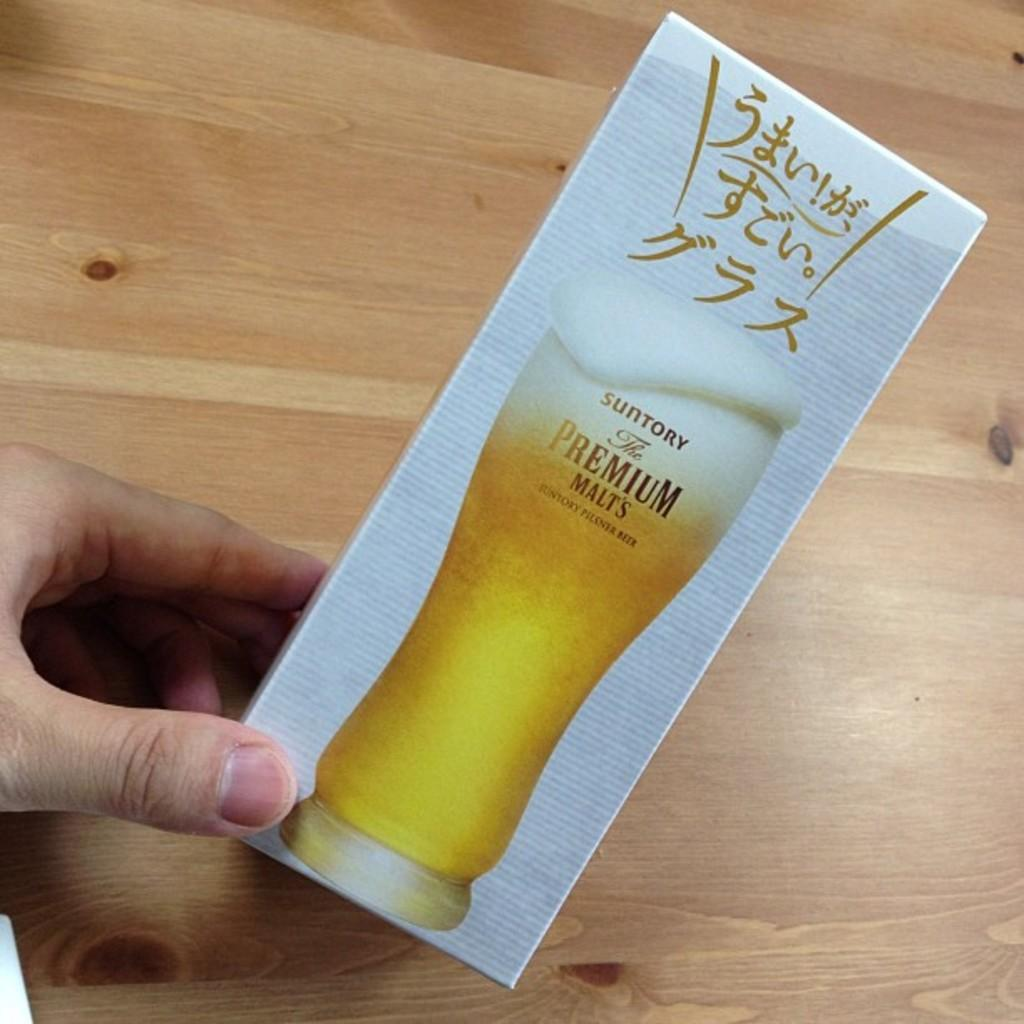What is being held by the hand in the image? The hand is holding a cardboard box. What is on top of the box? There is a glass on the box. What can be observed about the background of the image? The background of the image is brown in color. What type of lead can be seen in the image? There is no lead present in the image. Is there a wall visible in the image? The provided facts do not mention a wall, so it cannot be determined if one is present. --- Facts: 1. There is a person sitting on a chair in the image. 2. The person is holding a book. 3. The book has a blue cover. 4. There is a table next to the chair. 5. The table has a lamp on it. Absurd Topics: fish, ocean, boat Conversation: What is the person in the image doing? The person is sitting on a chair in the image. What is the person holding? The person is holding a book. What color is the book's cover? The book has a blue cover. What is located next to the chair? There is a table next to the chair. What is on the table? The table has a lamp on it. Reasoning: Let's think step by step in order to produce the conversation. We start by identifying the main subject in the image, which is the person sitting on a chair. Then, we describe what the person is holding, which is a book. Next, we mention the color of the book's cover, which is blue. Finally, we address the additional details of the table and lamp next to the chair. Absurd Question/Answer: Can you see any fish swimming in the ocean in the image? There is no ocean or fish present in the image. Is there a boat visible in the image? The provided facts do not mention a boat, so it cannot be determined if one is present. 